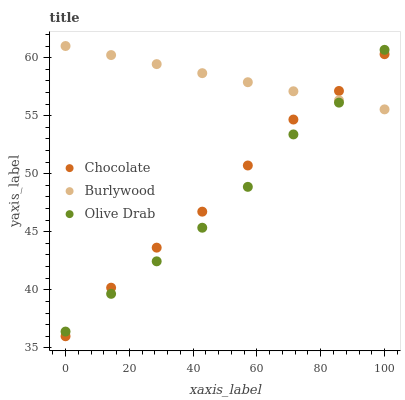Does Olive Drab have the minimum area under the curve?
Answer yes or no. Yes. Does Burlywood have the maximum area under the curve?
Answer yes or no. Yes. Does Chocolate have the minimum area under the curve?
Answer yes or no. No. Does Chocolate have the maximum area under the curve?
Answer yes or no. No. Is Burlywood the smoothest?
Answer yes or no. Yes. Is Olive Drab the roughest?
Answer yes or no. Yes. Is Chocolate the smoothest?
Answer yes or no. No. Is Chocolate the roughest?
Answer yes or no. No. Does Chocolate have the lowest value?
Answer yes or no. Yes. Does Olive Drab have the lowest value?
Answer yes or no. No. Does Burlywood have the highest value?
Answer yes or no. Yes. Does Olive Drab have the highest value?
Answer yes or no. No. Does Chocolate intersect Olive Drab?
Answer yes or no. Yes. Is Chocolate less than Olive Drab?
Answer yes or no. No. Is Chocolate greater than Olive Drab?
Answer yes or no. No. 